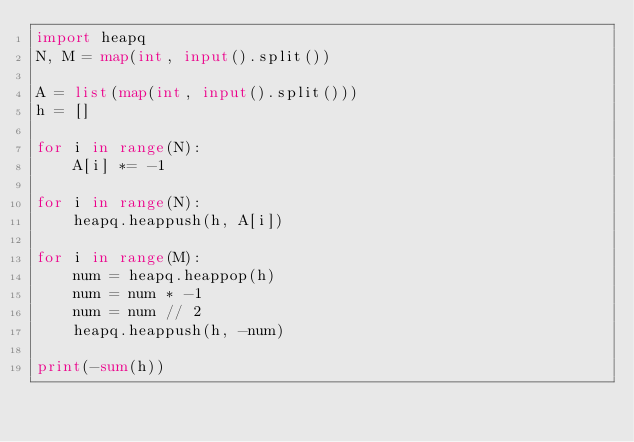Convert code to text. <code><loc_0><loc_0><loc_500><loc_500><_Python_>import heapq
N, M = map(int, input().split())

A = list(map(int, input().split()))
h = []

for i in range(N):
    A[i] *= -1

for i in range(N):
    heapq.heappush(h, A[i])

for i in range(M):
    num = heapq.heappop(h)
    num = num * -1
    num = num // 2
    heapq.heappush(h, -num)

print(-sum(h))
</code> 